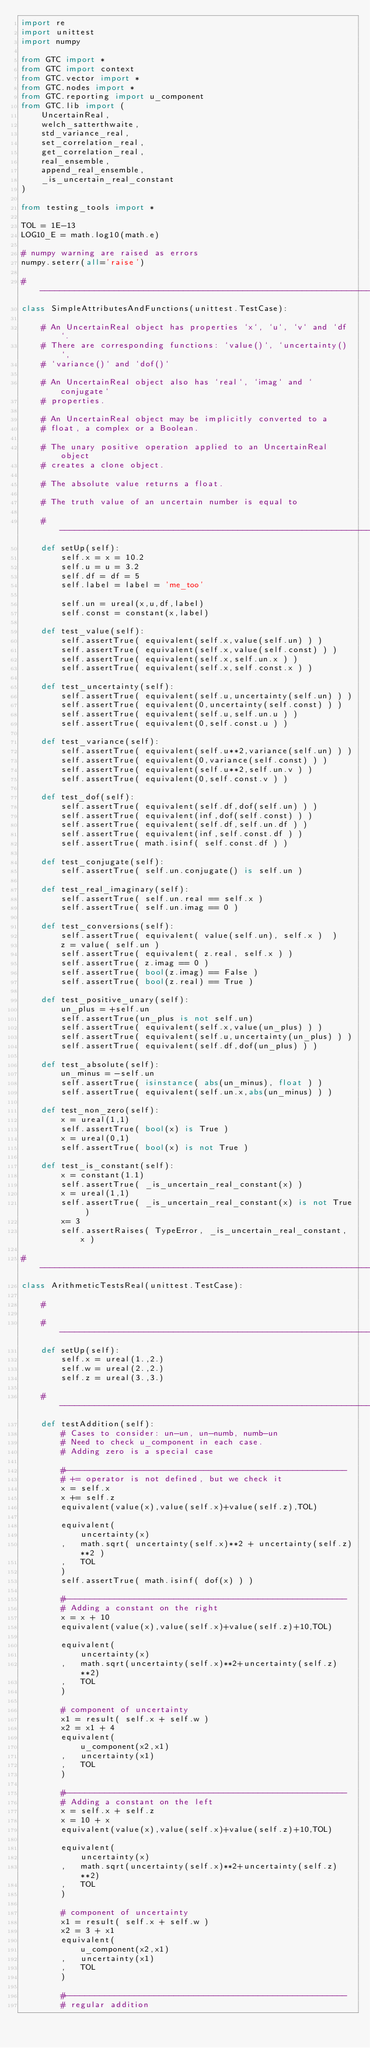<code> <loc_0><loc_0><loc_500><loc_500><_Python_>import re
import unittest
import numpy

from GTC import *
from GTC import context 
from GTC.vector import *
from GTC.nodes import *
from GTC.reporting import u_component
from GTC.lib import (
    UncertainReal,
    welch_satterthwaite,
    std_variance_real,
    set_correlation_real,
    get_correlation_real,
    real_ensemble,
    append_real_ensemble,
    _is_uncertain_real_constant
)

from testing_tools import *

TOL = 1E-13 
LOG10_E = math.log10(math.e)

# numpy warning are raised as errors
numpy.seterr(all='raise')

#----------------------------------------------------------------------------
class SimpleAttributesAndFunctions(unittest.TestCase):

    # An UncertainReal object has properties `x`, `u`, `v` and `df`.
    # There are corresponding functions: `value()`, `uncertainty()`, 
    # `variance()` and `dof()` 
    
    # An UncertainReal object also has `real`, `imag` and `conjugate`
    # properties.
    
    # An UncertainReal object may be implicitly converted to a 
    # float, a complex or a Boolean. 
    
    # The unary positive operation applied to an UncertainReal object 
    # creates a clone object.
    
    # The absolute value returns a float. 
    
    # The truth value of an uncertain number is equal to 

    #------------------------------------------------------------------------
    def setUp(self):
        self.x = x = 10.2
        self.u = u = 3.2
        self.df = df = 5
        self.label = label = 'me_too'
        
        self.un = ureal(x,u,df,label)
        self.const = constant(x,label)    
            
    def test_value(self):
        self.assertTrue( equivalent(self.x,value(self.un) ) )
        self.assertTrue( equivalent(self.x,value(self.const) ) )
        self.assertTrue( equivalent(self.x,self.un.x ) )
        self.assertTrue( equivalent(self.x,self.const.x ) )
      
    def test_uncertainty(self):
        self.assertTrue( equivalent(self.u,uncertainty(self.un) ) )
        self.assertTrue( equivalent(0,uncertainty(self.const) ) )
        self.assertTrue( equivalent(self.u,self.un.u ) )
        self.assertTrue( equivalent(0,self.const.u ) )
      
    def test_variance(self):
        self.assertTrue( equivalent(self.u**2,variance(self.un) ) )
        self.assertTrue( equivalent(0,variance(self.const) ) )
        self.assertTrue( equivalent(self.u**2,self.un.v ) )
        self.assertTrue( equivalent(0,self.const.v ) )
      
    def test_dof(self): 
        self.assertTrue( equivalent(self.df,dof(self.un) ) )
        self.assertTrue( equivalent(inf,dof(self.const) ) )
        self.assertTrue( equivalent(self.df,self.un.df ) )
        self.assertTrue( equivalent(inf,self.const.df ) )
        self.assertTrue( math.isinf( self.const.df ) )
 
    def test_conjugate(self):
        self.assertTrue( self.un.conjugate() is self.un )
        
    def test_real_imaginary(self):
        self.assertTrue( self.un.real == self.x )
        self.assertTrue( self.un.imag == 0 )
        
    def test_conversions(self):
        self.assertTrue( equivalent( value(self.un), self.x )  )
        z = value( self.un )
        self.assertTrue( equivalent( z.real, self.x ) )
        self.assertTrue( z.imag == 0 )
        self.assertTrue( bool(z.imag) == False )
        self.assertTrue( bool(z.real) == True )
        
    def test_positive_unary(self):
        un_plus = +self.un
        self.assertTrue(un_plus is not self.un)
        self.assertTrue( equivalent(self.x,value(un_plus) ) )
        self.assertTrue( equivalent(self.u,uncertainty(un_plus) ) )
        self.assertTrue( equivalent(self.df,dof(un_plus) ) )

    def test_absolute(self):
        un_minus = -self.un
        self.assertTrue( isinstance( abs(un_minus), float ) )
        self.assertTrue( equivalent(self.un.x,abs(un_minus) ) )

    def test_non_zero(self):
        x = ureal(1,1)
        self.assertTrue( bool(x) is True )
        x = ureal(0,1)
        self.assertTrue( bool(x) is not True )
        
    def test_is_constant(self): 
        x = constant(1.1)
        self.assertTrue( _is_uncertain_real_constant(x) )
        x = ureal(1,1)
        self.assertTrue( _is_uncertain_real_constant(x) is not True )
        x= 3
        self.assertRaises( TypeError, _is_uncertain_real_constant, x )
        
#----------------------------------------------------------------------------
class ArithmeticTestsReal(unittest.TestCase):

    # 
    
    #------------------------------------------------------------------------
    def setUp(self):
        self.x = ureal(1.,2.)
        self.w = ureal(2.,2.)
        self.z = ureal(3.,3.)
        
    #------------------------------------------------------------------------
    def testAddition(self):
        # Cases to consider: un-un, un-numb, numb-un
        # Need to check u_component in each case.
        # Adding zero is a special case
        
        #---------------------------------------------------------
        # += operator is not defined, but we check it
        x = self.x
        x += self.z
        equivalent(value(x),value(self.x)+value(self.z),TOL)
        
        equivalent(
            uncertainty(x)
        ,   math.sqrt( uncertainty(self.x)**2 + uncertainty(self.z)**2 )
        ,   TOL
        )
        self.assertTrue( math.isinf( dof(x) ) )

        #---------------------------------------------------------
        # Adding a constant on the right
        x = x + 10
        equivalent(value(x),value(self.x)+value(self.z)+10,TOL)
        
        equivalent(
            uncertainty(x)
        ,   math.sqrt(uncertainty(self.x)**2+uncertainty(self.z)**2)
        ,   TOL
        )

        # component of uncertainty
        x1 = result( self.x + self.w )
        x2 = x1 + 4
        equivalent(
            u_component(x2,x1)
        ,   uncertainty(x1)
        ,   TOL
        )
        
        #---------------------------------------------------------
        # Adding a constant on the left
        x = self.x + self.z
        x = 10 + x
        equivalent(value(x),value(self.x)+value(self.z)+10,TOL)
        
        equivalent(
            uncertainty(x)
        ,   math.sqrt(uncertainty(self.x)**2+uncertainty(self.z)**2)
        ,   TOL
        )
        
        # component of uncertainty
        x1 = result( self.x + self.w )
        x2 = 3 + x1
        equivalent(
            u_component(x2,x1)
        ,   uncertainty(x1)
        ,   TOL
        )

        #---------------------------------------------------------
        # regular addition</code> 